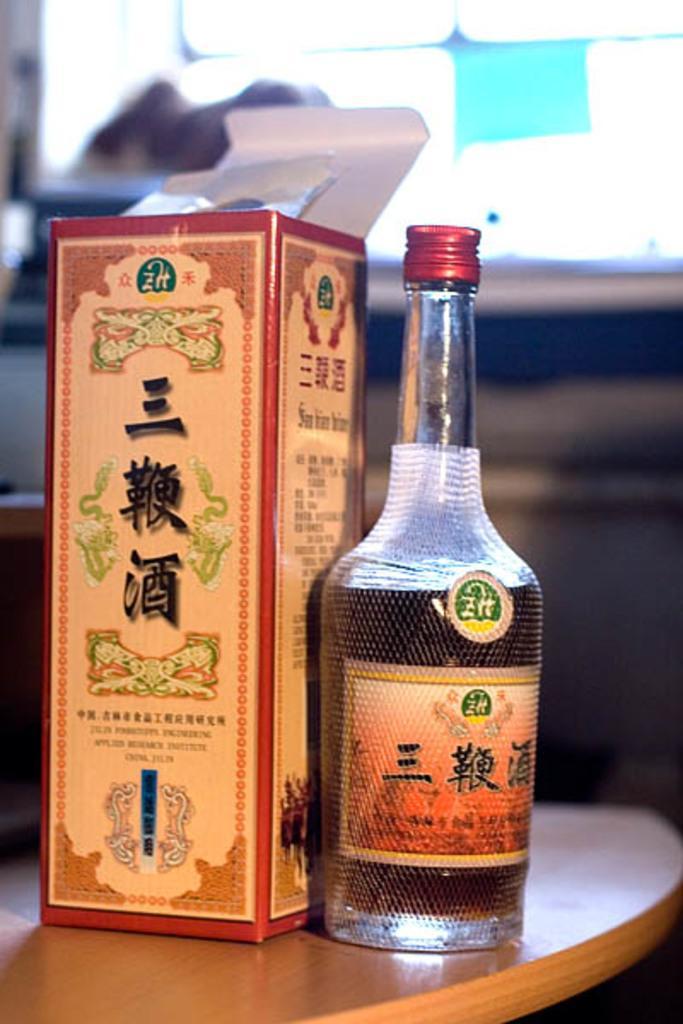Describe this image in one or two sentences. In the image we can see bottle and bottle cover on the table. Bottle we can see some liquid is filled in it. 